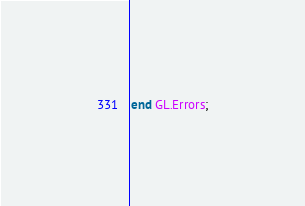Convert code to text. <code><loc_0><loc_0><loc_500><loc_500><_Ada_>end GL.Errors;
</code> 